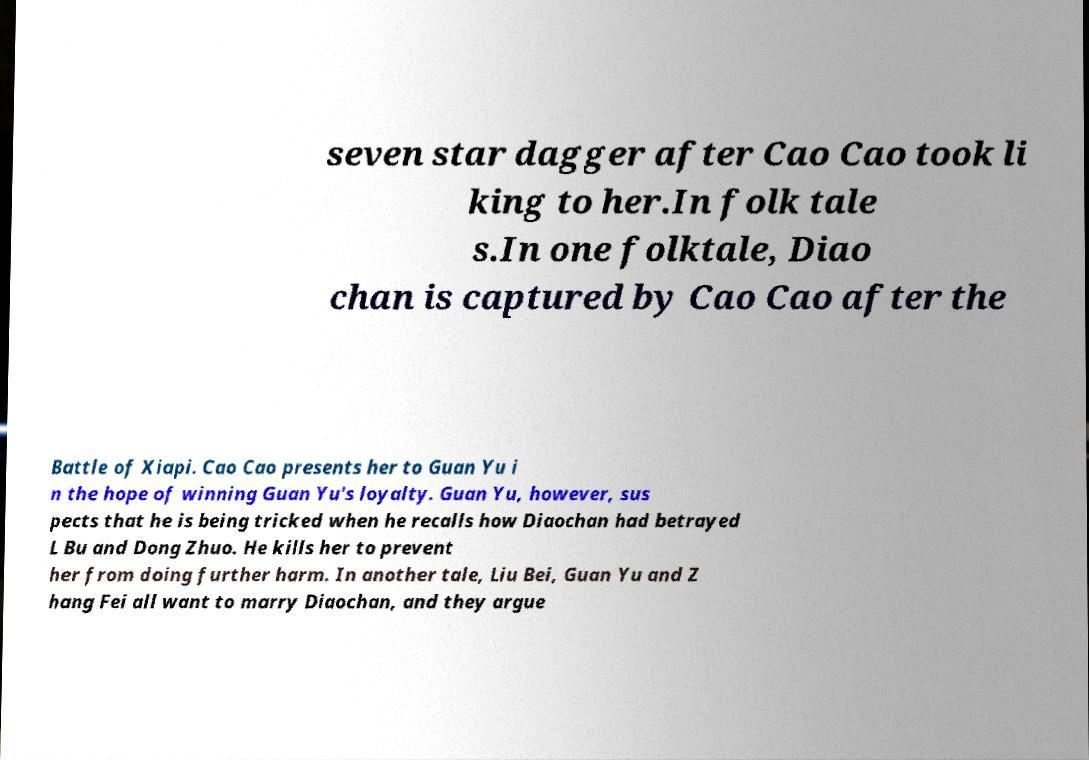For documentation purposes, I need the text within this image transcribed. Could you provide that? seven star dagger after Cao Cao took li king to her.In folk tale s.In one folktale, Diao chan is captured by Cao Cao after the Battle of Xiapi. Cao Cao presents her to Guan Yu i n the hope of winning Guan Yu's loyalty. Guan Yu, however, sus pects that he is being tricked when he recalls how Diaochan had betrayed L Bu and Dong Zhuo. He kills her to prevent her from doing further harm. In another tale, Liu Bei, Guan Yu and Z hang Fei all want to marry Diaochan, and they argue 